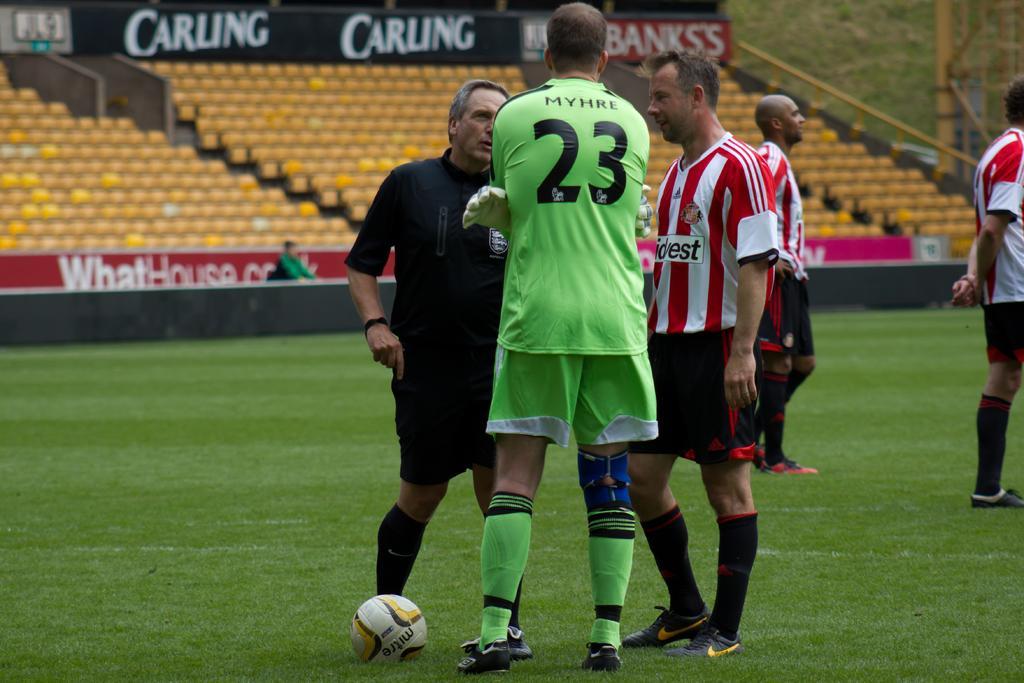How would you summarize this image in a sentence or two? In the center of the image there are people standing in grass. There is a ball. In the background of the image there are chairs. There is a advertisement board. 